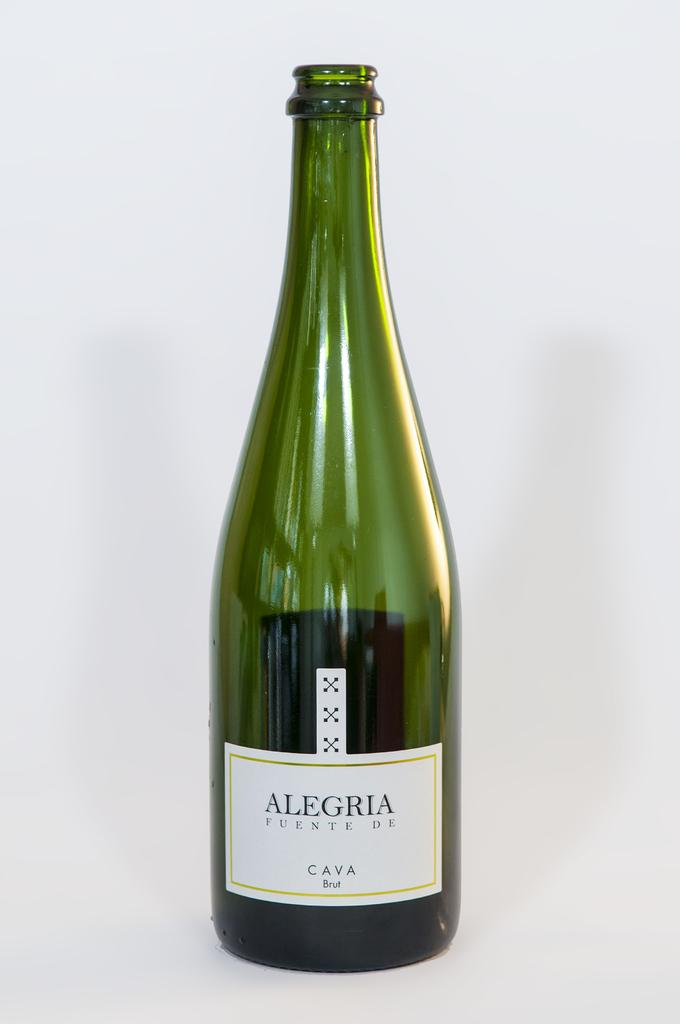Provide a one-sentence caption for the provided image. A bottle of Alegria Fuente de Cava Brut sits with its cork off. 